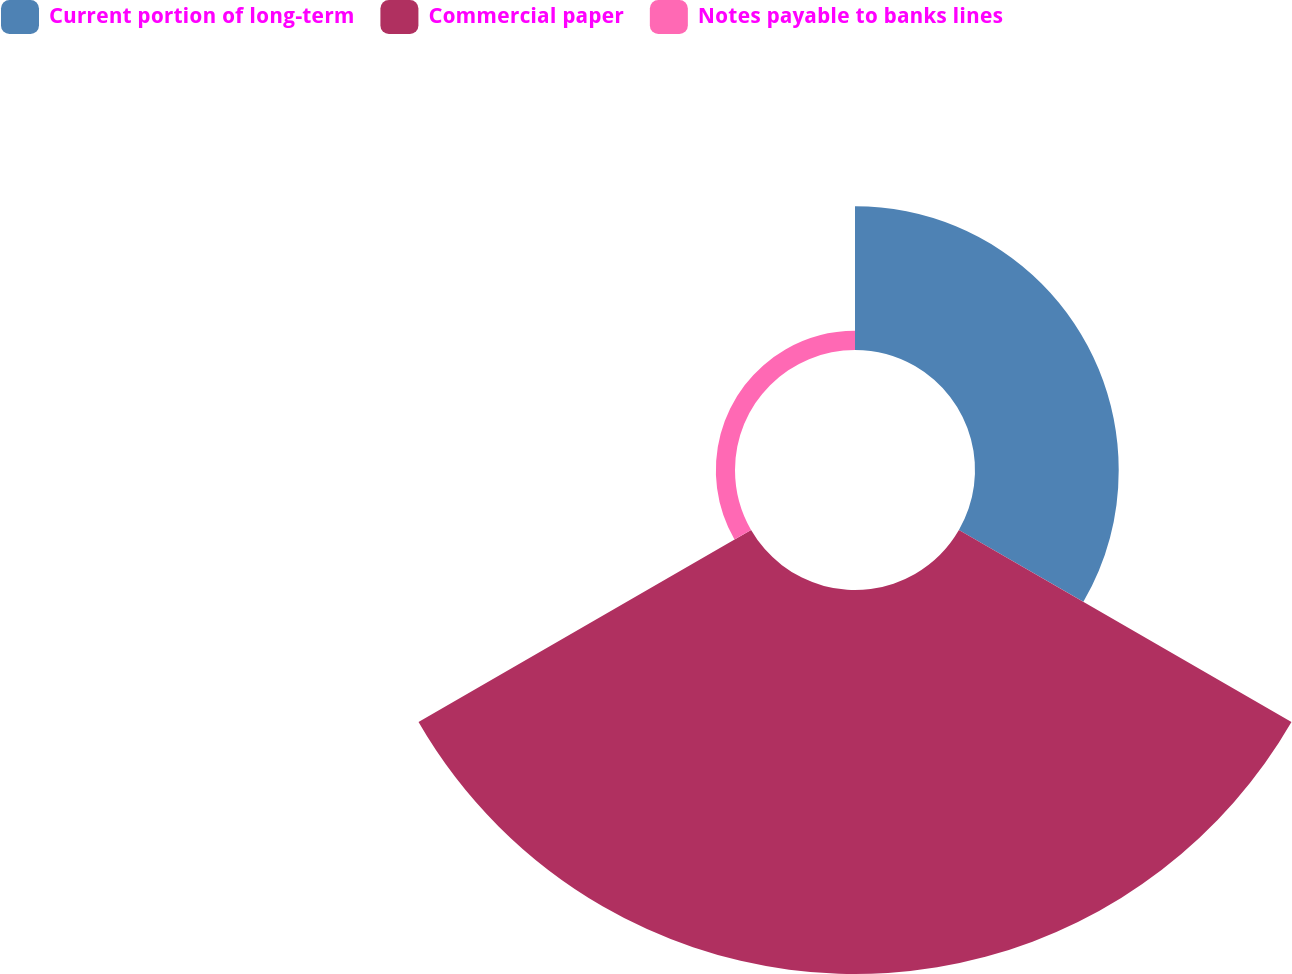Convert chart. <chart><loc_0><loc_0><loc_500><loc_500><pie_chart><fcel>Current portion of long-term<fcel>Commercial paper<fcel>Notes payable to banks lines<nl><fcel>26.28%<fcel>70.22%<fcel>3.5%<nl></chart> 